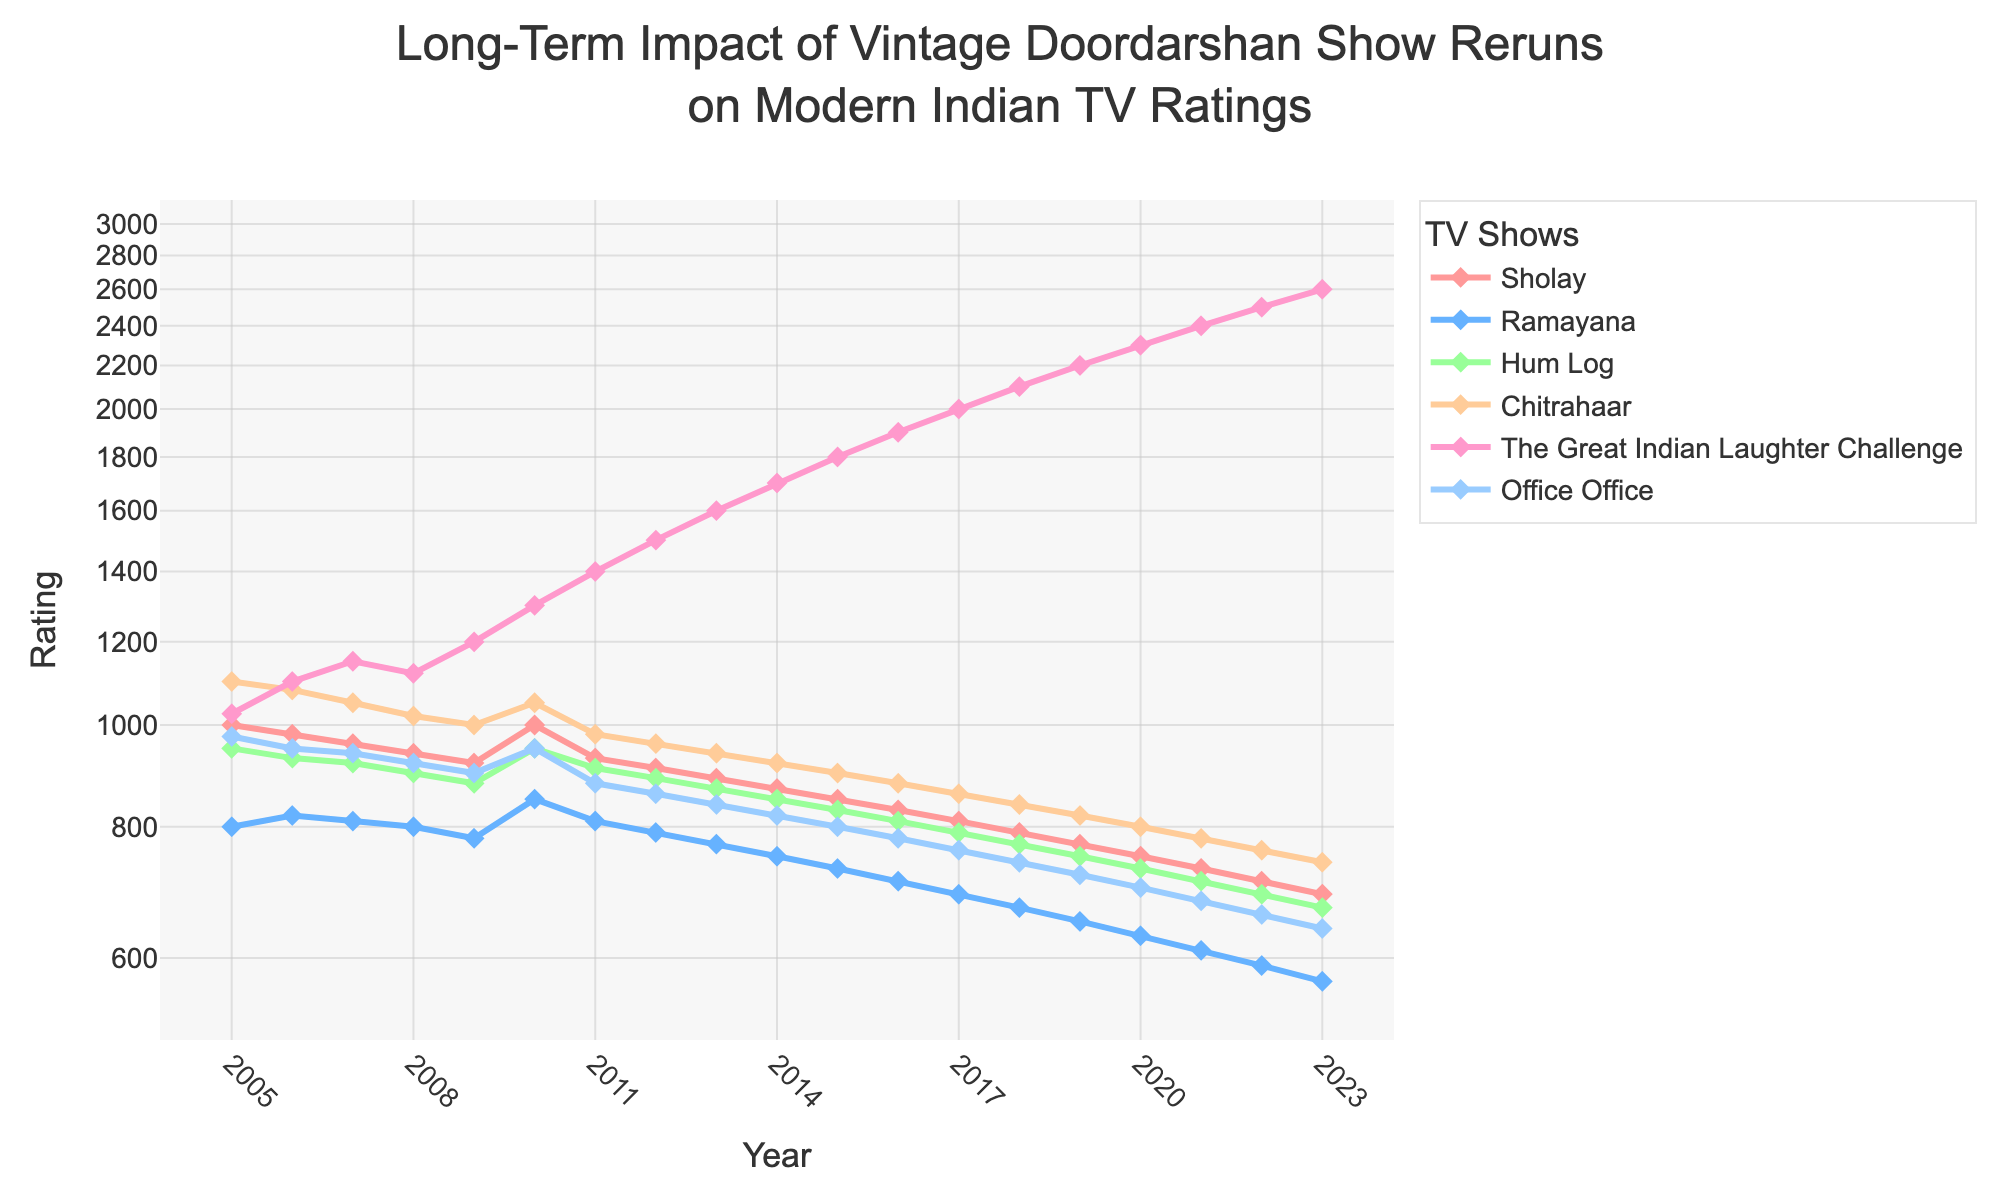What are the titles of the TV shows plotted in the figure? The titles of the TV shows are displayed in the legend section of the plot, with each show represented by a distinct color and line style.
Answer: Sholay, Ramayana, Hum Log, Chitrahaar, The Great Indian Laughter Challenge, Office Office How does the rating of 'Hum Log' change from 2010 to 2020? Look at the line corresponding to 'Hum Log'. In 2010, Hum Log's rating is visible as approximately 950, and it decreases steadily each year. By 2020, the rating is about 730.
Answer: Decreases Which TV show had the highest rating in 2023? To determine the highest rating for 2023, observe the end points of all the TV show lines and identify the one with the highest value on the Y-axis. 'The Great Indian Laughter Challenge' is the highest at around 2600.
Answer: The Great Indian Laughter Challenge What is the trend of the ratings for 'Chitrahaar' over the years? 'Chitrahaar' shows a consistent downward trend. Starting from around 1100 in 2005, its rating steadily declines each year until it reaches around 740 in 2023.
Answer: Decreasing Between 2008 and 2011, which show's rating did not follow a smooth decreasing trend? Examine the ratings from 2008 to 2011. 'Sholay' remains relatively stable, while 'Ramayana' shows a slight increase around 2010. Hence 'Sholay' and 'Ramayana' show deviations.
Answer: Sholay and Ramayana What is the average rating of 'Office Office' between 2005 and 2023? Add up the ratings of 'Office Office' from 2005 to 2023 and divide by the total number of years (19).
Answer: (975 + 950 + 940 + 920 + 900 + 950 + 880 + 860 + 840 + 820 + 800 + 780 + 760 + 740 + 720 + 700 + 680 + 660 + 640) / 19 = 820 Which two shows have the closest ratings in the year 2015? Compare the 2015 ratings for all shows and find the pair with the smallest difference. 'Ramayana' and 'Hum Log' both have ratings around 730 and 830, respectively.
Answer: Ramayana and Hum Log Which show has the most significant rating increase from 2009 to 2010? Compare the rating differences between the two years for all shows. 'Office Office' increased from 900 to 950, while other shows either decreased or had smaller increases.
Answer: Office Office What is the difference in ratings of 'The Great Indian Laughter Challenge' from 2005 to 2023? Take the difference of the show's rating in the starting year (1025 in 2005) and the end year (2600 in 2023).
Answer: 2600 - 1025 = 1575 During which year did 'Chitrahaar' have the same rating as it did in 2020? Look at 'Chitrahaar's' ratings and identify any year when its rating was close to 800, as it was in 2020. In 2005, 'Chitrahaar’ has a rating close to 1100.
Answer: No year 